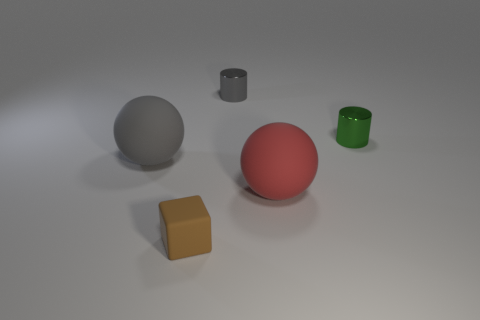How many large things are red metallic spheres or brown matte blocks?
Your response must be concise. 0. There is a big ball that is to the left of the gray metal cylinder; does it have the same color as the tiny metallic cylinder that is behind the green metal object?
Your answer should be very brief. Yes. Is there another object made of the same material as the red object?
Offer a terse response. Yes. How many brown objects are tiny metallic cylinders or large cylinders?
Your answer should be compact. 0. Are there more large balls that are on the left side of the brown rubber thing than small metallic balls?
Offer a terse response. Yes. Is the size of the block the same as the green thing?
Your answer should be compact. Yes. There is another cylinder that is made of the same material as the green cylinder; what is its color?
Give a very brief answer. Gray. Are there the same number of green metallic things on the right side of the tiny brown cube and brown cubes behind the tiny green shiny thing?
Your answer should be very brief. No. There is a metal object that is to the left of the ball on the right side of the tiny block; what is its shape?
Offer a terse response. Cylinder. There is another small object that is the same shape as the small gray object; what is it made of?
Your answer should be compact. Metal. 